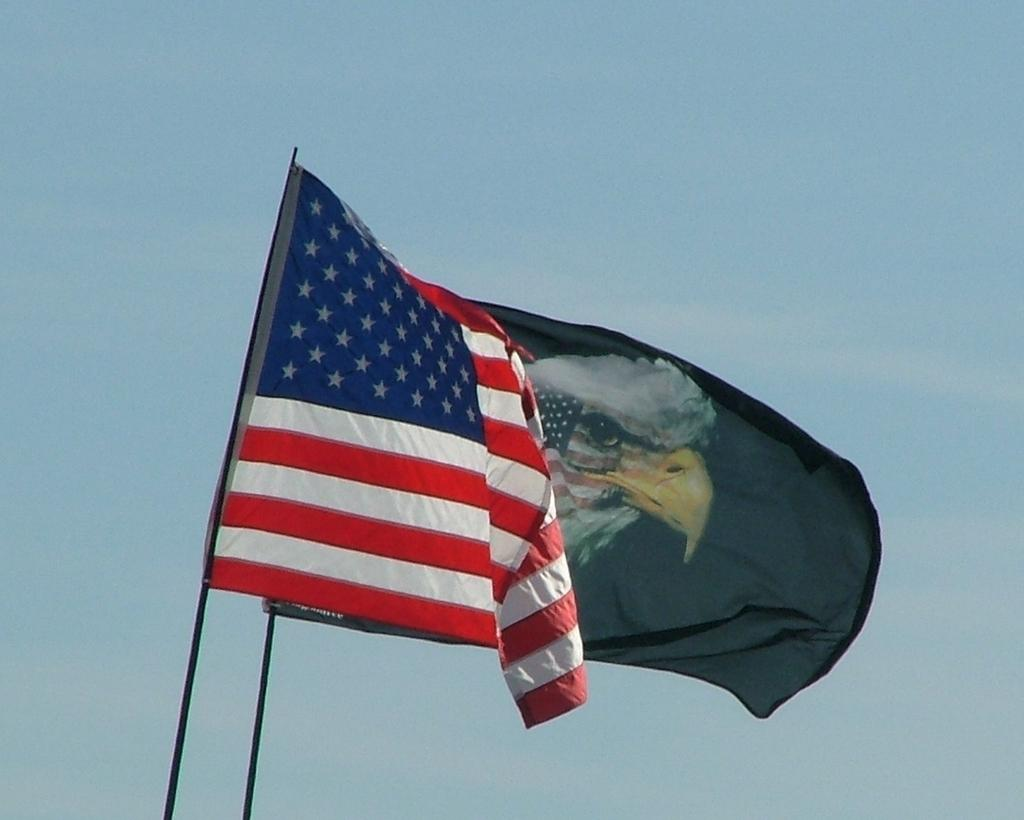How many flags can be seen in the image? There are two flags in the image. What are the flags doing in the image? The flags are flying. What can be seen in the background of the image? The sky is visible in the image. What is the condition of the sky in the image? There are clouds in the sky. Can you tell me how many chickens are perched on the rock in the image? There are no chickens or rocks present in the image; it only features two flags and a sky with clouds. 